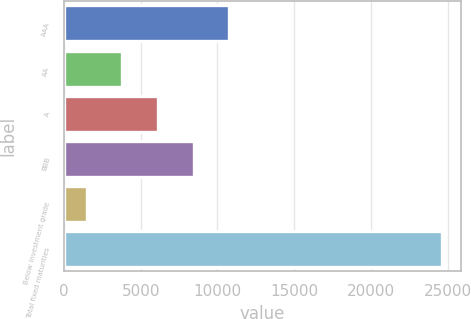Convert chart to OTSL. <chart><loc_0><loc_0><loc_500><loc_500><bar_chart><fcel>AAA<fcel>AA<fcel>A<fcel>BBB<fcel>Below investment grade<fcel>Total fixed maturities<nl><fcel>10758.4<fcel>3810.1<fcel>6126.2<fcel>8442.3<fcel>1494<fcel>24655<nl></chart> 